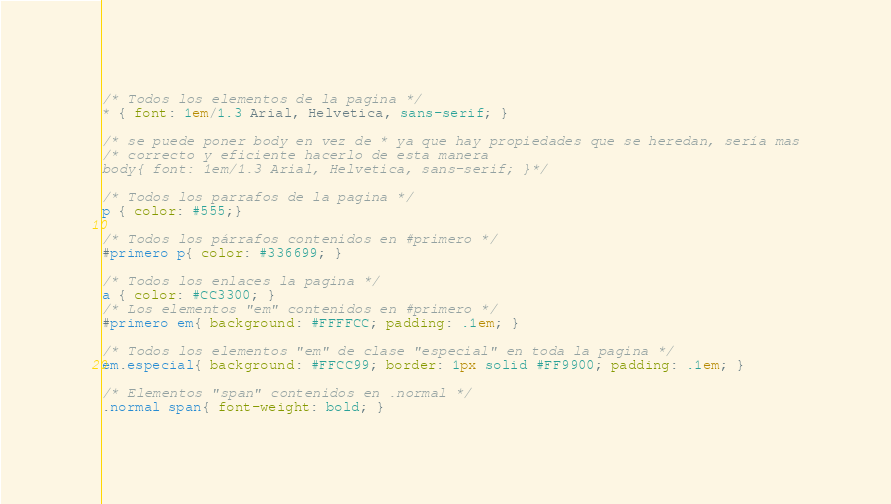<code> <loc_0><loc_0><loc_500><loc_500><_CSS_>/* Todos los elementos de la pagina */
* { font: 1em/1.3 Arial, Helvetica, sans-serif; }

/* se puede poner body en vez de * ya que hay propiedades que se heredan, sería mas
/* correcto y eficiente hacerlo de esta manera
body{ font: 1em/1.3 Arial, Helvetica, sans-serif; }*/

/* Todos los parrafos de la pagina */
p { color: #555;}

/* Todos los párrafos contenidos en #primero */
#primero p{ color: #336699; }

/* Todos los enlaces la pagina */
a { color: #CC3300; }
/* Los elementos "em" contenidos en #primero */
#primero em{ background: #FFFFCC; padding: .1em; }

/* Todos los elementos "em" de clase "especial" en toda la pagina */
em.especial{ background: #FFCC99; border: 1px solid #FF9900; padding: .1em; }

/* Elementos "span" contenidos en .normal */
.normal span{ font-weight: bold; }</code> 